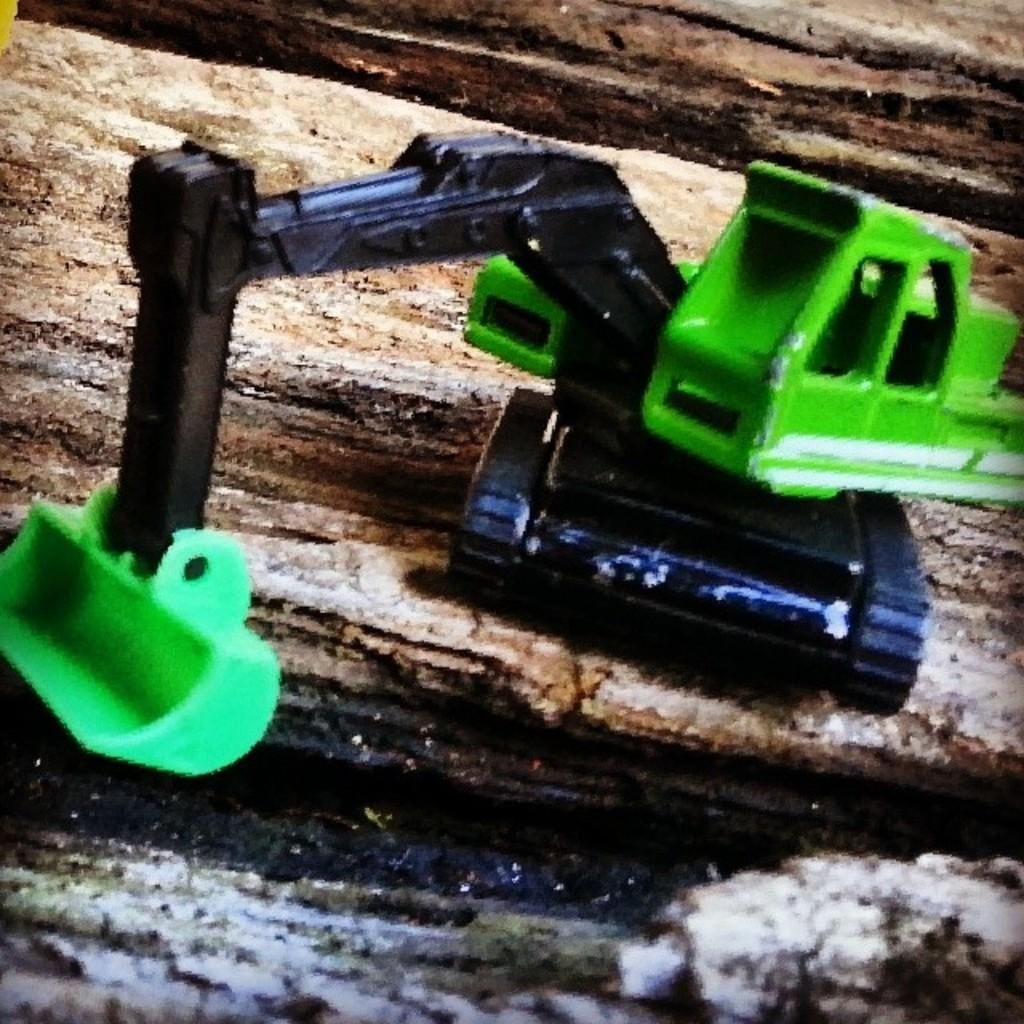What type of toy is present in the image? There is a JCB toy in the image. What colors can be seen on the JCB toy? The JCB toy is green and black in color. What is the JCB toy placed on in the image? The JCB toy is placed on an object. How many mice are sitting on the JCB toy in the image? There are no mice present in the image; it only features a JCB toy. What type of fruit is being used as a hat for the JCB toy in the image? There is no fruit or hat present on the JCB toy in the image. 